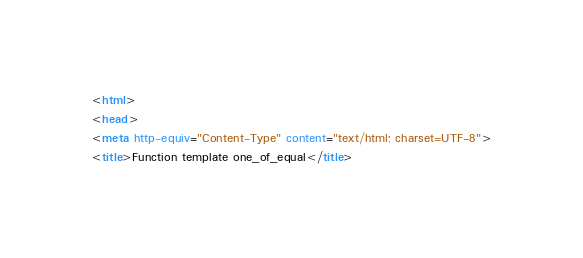<code> <loc_0><loc_0><loc_500><loc_500><_HTML_><html>
<head>
<meta http-equiv="Content-Type" content="text/html; charset=UTF-8">
<title>Function template one_of_equal</title></code> 